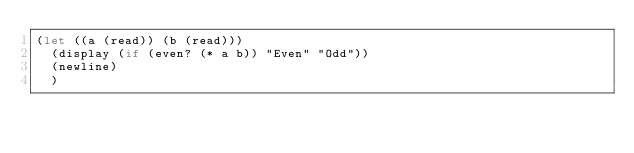Convert code to text. <code><loc_0><loc_0><loc_500><loc_500><_Scheme_>(let ((a (read)) (b (read)))
  (display (if (even? (* a b)) "Even" "Odd"))
  (newline)
  )
</code> 